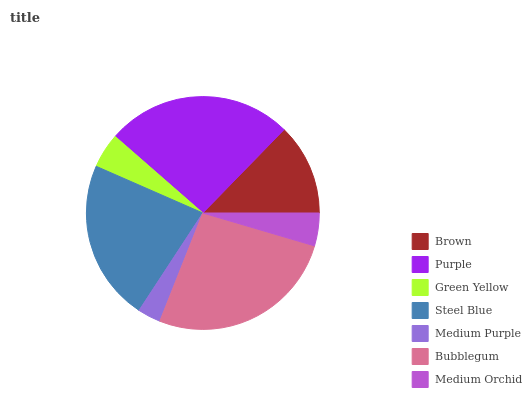Is Medium Purple the minimum?
Answer yes or no. Yes. Is Bubblegum the maximum?
Answer yes or no. Yes. Is Purple the minimum?
Answer yes or no. No. Is Purple the maximum?
Answer yes or no. No. Is Purple greater than Brown?
Answer yes or no. Yes. Is Brown less than Purple?
Answer yes or no. Yes. Is Brown greater than Purple?
Answer yes or no. No. Is Purple less than Brown?
Answer yes or no. No. Is Brown the high median?
Answer yes or no. Yes. Is Brown the low median?
Answer yes or no. Yes. Is Medium Purple the high median?
Answer yes or no. No. Is Medium Purple the low median?
Answer yes or no. No. 